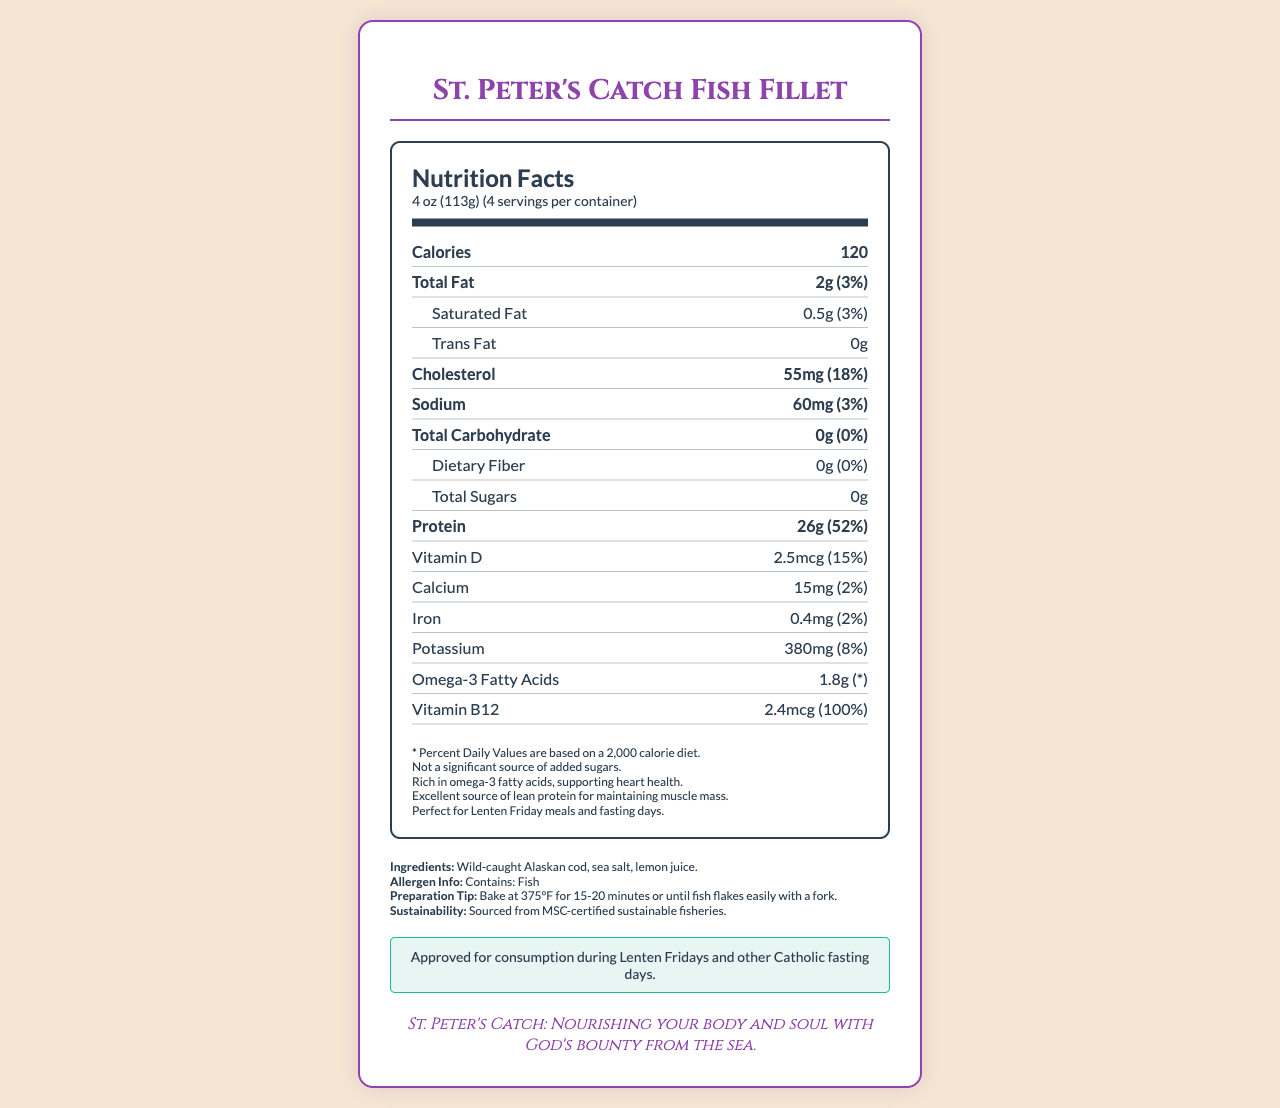what is the serving size? The serving size is listed at the top of the Nutrition Facts section as "4 oz (113g)".
Answer: 4 oz (113g) how many calories are there per serving? The number of calories per serving is clearly indicated in the bold nutrition item that states "Calories 120".
Answer: 120 what percentage of the daily value of protein does one serving provide? The protein content lists "26g" and "(52%)" right next to it, indicating that one serving provides 52% of the daily value for protein.
Answer: 52% what are the three main ingredients in this fish fillet? Under the additional information section towards the bottom of the document, it states "Ingredients: Wild-caught Alaskan cod, sea salt, lemon juice".
Answer: Wild-caught Alaskan cod, sea salt, lemon juice how long should you bake the fish fillet, and at what temperature? The preparation tip section says, "Bake at 375°F for 15-20 minutes or until fish flakes easily with a fork".
Answer: Bake at 375°F for 15-20 minutes what is the amount of Omega-3 fatty acids per serving? The amount of Omega-3 fatty acids per serving is given as "1.8g" in the nutrition item section.
Answer: 1.8g how many servings are in each container? At the top of the Nutrition Facts section, it indicates there are "4 servings per container".
Answer: 4 what is the amount of cholesterol per serving, and what percentage of the daily value does this represent? The cholesterol content is listed as "55mg (18%)" in the document.
Answer: 55mg, 18% Is it safe for someone with a fish allergy to consume this product? The allergen information states "Contains: Fish", indicating it is not safe for someone with a fish allergy.
Answer: No describe the main points of the Nutrition Facts Label for this fish fillet. The document contains a detailed breakdown of the nutritional content per serving, preparation tips, ingredient list, allergen information, as well as religious and sustainability statements.
Answer: The document provides nutrition facts for St. Peter's Catch Fish Fillet, detailing serving size, calories, fats, cholesterol, sodium, carbohydrates, protein, vitamins, and minerals. It highlights high protein and Omega-3 content, mentions ingredients, allergen information, preparation instructions, sustainability certification, and religious approval for consumption during fasting days. what is the primary nutrient benefit that this fish fillet offers according to the document? The document mentions "Excellent source of lean protein for maintaining muscle mass" and "Rich in omega-3 fatty acids, supporting heart health" in the additional info section.
Answer: High protein and omega-3 fatty acids which nutrient is not considered a significant source according to the document? The additional info section states, "Not a significant source of added sugars".
Answer: Total Sugars what is the daily value percentage of Vitamin B12 per serving? A. 50% B. 75% C. 100% D. 150% The daily value percentage of Vitamin B12 per serving is listed as "100%" in the nutrition item section for Vitamin B12.
Answer: C. 100% what certification indicates the fish is sourced sustainably? A. MSC-certified B. NOAA-certified C. FDA-certified D. USDA-certified The sustainability info section states "Sourced from MSC-certified sustainable fisheries," indicating MSC certification.
Answer: A. MSC-certified how much potassium does one serving provide? The nutrition item section lists the amount of potassium per serving as "380mg".
Answer: 380mg is the fish fillet approved for consumption during Lenten Fridays? The religious note clearly states that the product is "Approved for consumption during Lenten Fridays and other Catholic fasting days."
Answer: Yes what is the brand statement at the bottom of the document? The brand statement at the bottom of the document reads, "St. Peter's Catch: Nourishing your body and soul with God's bounty from the sea."
Answer: St. Peter's Catch: Nourishing your body and soul with God's bounty from the sea. what is the percentage daily value of total fat in one serving? The document lists the total fat content as "2g (3%)".
Answer: 3% Can you determine if the fish fillet is gluten-free from the document? The document does not provide any information specifically stating whether the fish fillet is gluten-free or not.
Answer: Not enough information 